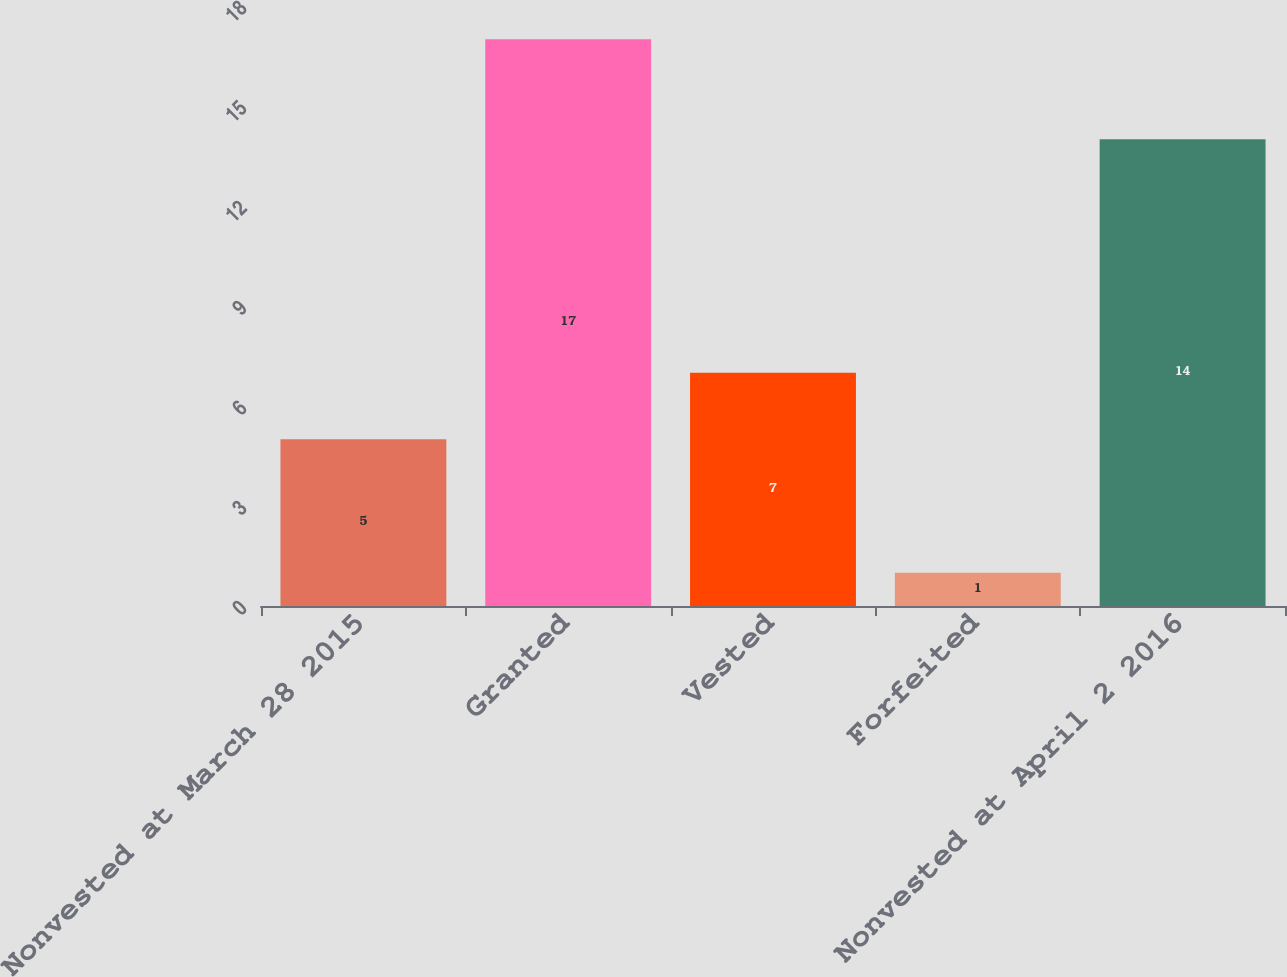Convert chart. <chart><loc_0><loc_0><loc_500><loc_500><bar_chart><fcel>Nonvested at March 28 2015<fcel>Granted<fcel>Vested<fcel>Forfeited<fcel>Nonvested at April 2 2016<nl><fcel>5<fcel>17<fcel>7<fcel>1<fcel>14<nl></chart> 